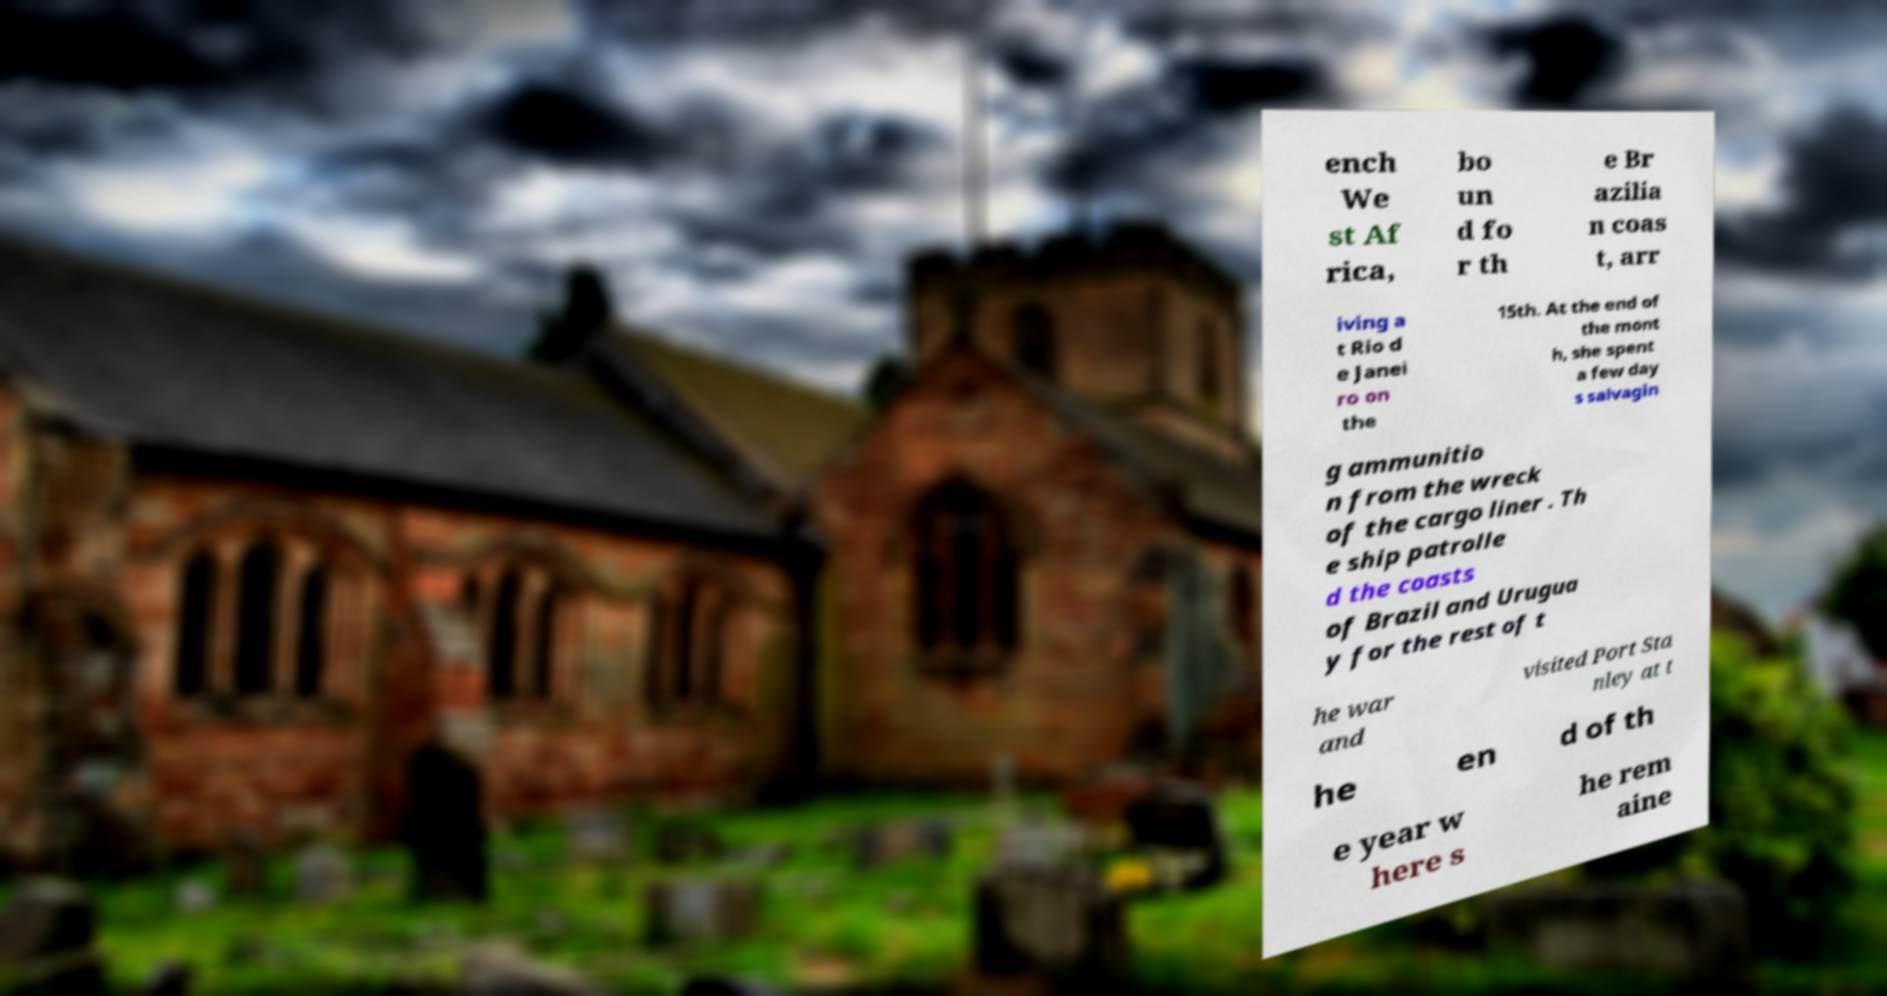Could you extract and type out the text from this image? ench We st Af rica, bo un d fo r th e Br azilia n coas t, arr iving a t Rio d e Janei ro on the 15th. At the end of the mont h, she spent a few day s salvagin g ammunitio n from the wreck of the cargo liner . Th e ship patrolle d the coasts of Brazil and Urugua y for the rest of t he war and visited Port Sta nley at t he en d of th e year w here s he rem aine 